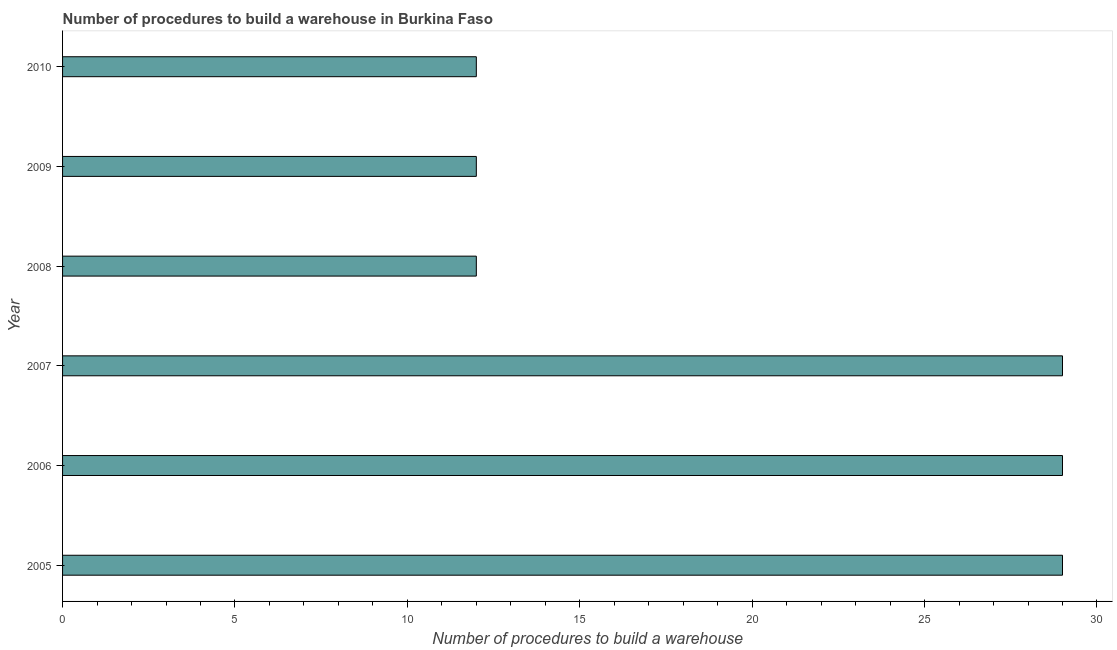Does the graph contain any zero values?
Your response must be concise. No. What is the title of the graph?
Your answer should be compact. Number of procedures to build a warehouse in Burkina Faso. What is the label or title of the X-axis?
Provide a succinct answer. Number of procedures to build a warehouse. What is the label or title of the Y-axis?
Give a very brief answer. Year. In which year was the number of procedures to build a warehouse maximum?
Your response must be concise. 2005. In which year was the number of procedures to build a warehouse minimum?
Ensure brevity in your answer.  2008. What is the sum of the number of procedures to build a warehouse?
Give a very brief answer. 123. What is the average number of procedures to build a warehouse per year?
Provide a succinct answer. 20. What is the median number of procedures to build a warehouse?
Keep it short and to the point. 20.5. Do a majority of the years between 2009 and 2007 (inclusive) have number of procedures to build a warehouse greater than 29 ?
Your response must be concise. Yes. What is the ratio of the number of procedures to build a warehouse in 2007 to that in 2008?
Give a very brief answer. 2.42. What is the difference between the highest and the second highest number of procedures to build a warehouse?
Make the answer very short. 0. What is the difference between the highest and the lowest number of procedures to build a warehouse?
Provide a succinct answer. 17. Are all the bars in the graph horizontal?
Offer a very short reply. Yes. What is the difference between two consecutive major ticks on the X-axis?
Offer a terse response. 5. What is the Number of procedures to build a warehouse in 2005?
Offer a very short reply. 29. What is the Number of procedures to build a warehouse of 2007?
Ensure brevity in your answer.  29. What is the Number of procedures to build a warehouse of 2008?
Provide a short and direct response. 12. What is the difference between the Number of procedures to build a warehouse in 2005 and 2008?
Make the answer very short. 17. What is the difference between the Number of procedures to build a warehouse in 2005 and 2010?
Make the answer very short. 17. What is the difference between the Number of procedures to build a warehouse in 2006 and 2007?
Your answer should be compact. 0. What is the difference between the Number of procedures to build a warehouse in 2006 and 2009?
Keep it short and to the point. 17. What is the difference between the Number of procedures to build a warehouse in 2006 and 2010?
Your answer should be very brief. 17. What is the difference between the Number of procedures to build a warehouse in 2007 and 2009?
Your answer should be very brief. 17. What is the difference between the Number of procedures to build a warehouse in 2009 and 2010?
Your response must be concise. 0. What is the ratio of the Number of procedures to build a warehouse in 2005 to that in 2006?
Make the answer very short. 1. What is the ratio of the Number of procedures to build a warehouse in 2005 to that in 2007?
Offer a terse response. 1. What is the ratio of the Number of procedures to build a warehouse in 2005 to that in 2008?
Ensure brevity in your answer.  2.42. What is the ratio of the Number of procedures to build a warehouse in 2005 to that in 2009?
Make the answer very short. 2.42. What is the ratio of the Number of procedures to build a warehouse in 2005 to that in 2010?
Your answer should be compact. 2.42. What is the ratio of the Number of procedures to build a warehouse in 2006 to that in 2007?
Offer a very short reply. 1. What is the ratio of the Number of procedures to build a warehouse in 2006 to that in 2008?
Offer a very short reply. 2.42. What is the ratio of the Number of procedures to build a warehouse in 2006 to that in 2009?
Your answer should be compact. 2.42. What is the ratio of the Number of procedures to build a warehouse in 2006 to that in 2010?
Provide a succinct answer. 2.42. What is the ratio of the Number of procedures to build a warehouse in 2007 to that in 2008?
Give a very brief answer. 2.42. What is the ratio of the Number of procedures to build a warehouse in 2007 to that in 2009?
Your answer should be compact. 2.42. What is the ratio of the Number of procedures to build a warehouse in 2007 to that in 2010?
Your response must be concise. 2.42. What is the ratio of the Number of procedures to build a warehouse in 2008 to that in 2010?
Your answer should be very brief. 1. 